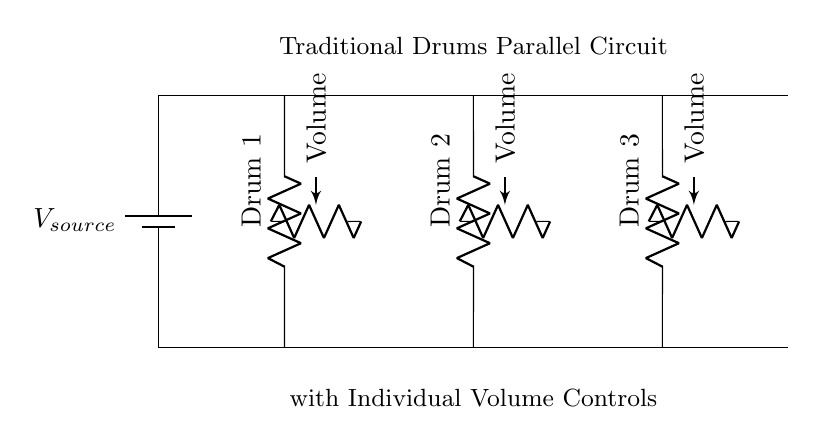What is the type of the power source? The circuit uses a battery as the power source, denoted by the symbol for a battery in the circuit diagram.
Answer: Battery How many drums are in the circuit? The diagram shows three drums connected in parallel, represented by three separate resistor symbols labeled Drum 1, Drum 2, and Drum 3.
Answer: Three What is the function of the volume controls? The volume controls serve to adjust the resistance for each drum individually, which allows for the customization of sound output for each drum.
Answer: Adjust sound What is the arrangement of the drums in the circuit? The drums are arranged in a parallel connection, indicated by the separate branches connecting each drum to the main voltage lines without sharing current.
Answer: Parallel What happens to the current flowing through each drum? In a parallel circuit, the total current supplied by the power source is divided among the branches, with each drum receiving its own share of the current based on its resistance.
Answer: Divided How does adding more drums affect the total resistance of the circuit? Adding more drums in parallel decreases the total resistance of the circuit, as parallel resistors have a combined resistance that is less than any individual resistance in the circuit.
Answer: Decreases 